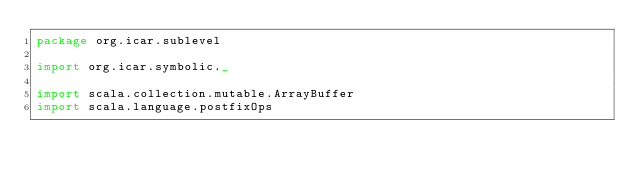Convert code to text. <code><loc_0><loc_0><loc_500><loc_500><_Scala_>package org.icar.sublevel

import org.icar.symbolic._

import scala.collection.mutable.ArrayBuffer
import scala.language.postfixOps
</code> 